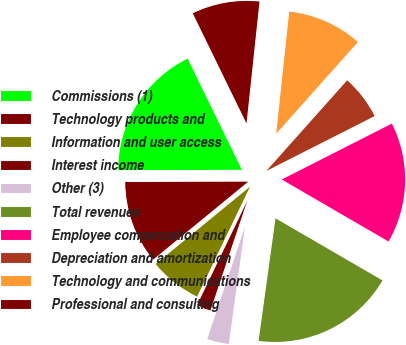Convert chart to OTSL. <chart><loc_0><loc_0><loc_500><loc_500><pie_chart><fcel>Commissions (1)<fcel>Technology products and<fcel>Information and user access<fcel>Interest income<fcel>Other (3)<fcel>Total revenues<fcel>Employee compensation and<fcel>Depreciation and amortization<fcel>Technology and communications<fcel>Professional and consulting<nl><fcel>17.82%<fcel>10.89%<fcel>6.93%<fcel>1.98%<fcel>2.97%<fcel>18.81%<fcel>15.84%<fcel>5.94%<fcel>9.9%<fcel>8.91%<nl></chart> 